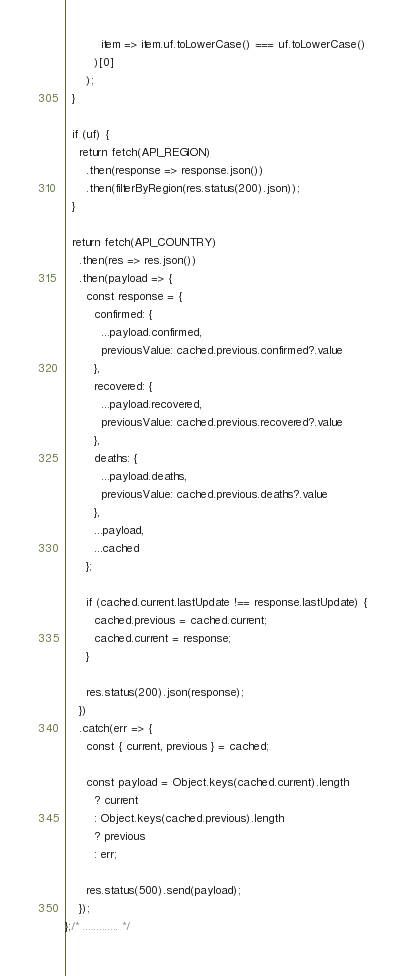<code> <loc_0><loc_0><loc_500><loc_500><_JavaScript_>          item => item.uf.toLowerCase() === uf.toLowerCase()
        )[0]
      );
  }

  if (uf) {
    return fetch(API_REGION)
      .then(response => response.json())
      .then(filterByRegion(res.status(200).json));
  }

  return fetch(API_COUNTRY)
    .then(res => res.json())
    .then(payload => {
      const response = {
        confirmed: {
          ...payload.confirmed,
          previousValue: cached.previous.confirmed?.value
        },
        recovered: {
          ...payload.recovered,
          previousValue: cached.previous.recovered?.value
        },
        deaths: {
          ...payload.deaths,
          previousValue: cached.previous.deaths?.value
        },
        ...payload,
        ...cached
      };

      if (cached.current.lastUpdate !== response.lastUpdate) {
        cached.previous = cached.current;
        cached.current = response;
      }

      res.status(200).json(response);
    })
    .catch(err => {
      const { current, previous } = cached;

      const payload = Object.keys(cached.current).length
        ? current
        : Object.keys(cached.previous).length
        ? previous
        : err;

      res.status(500).send(payload);
    });
};/* ............. */
</code> 